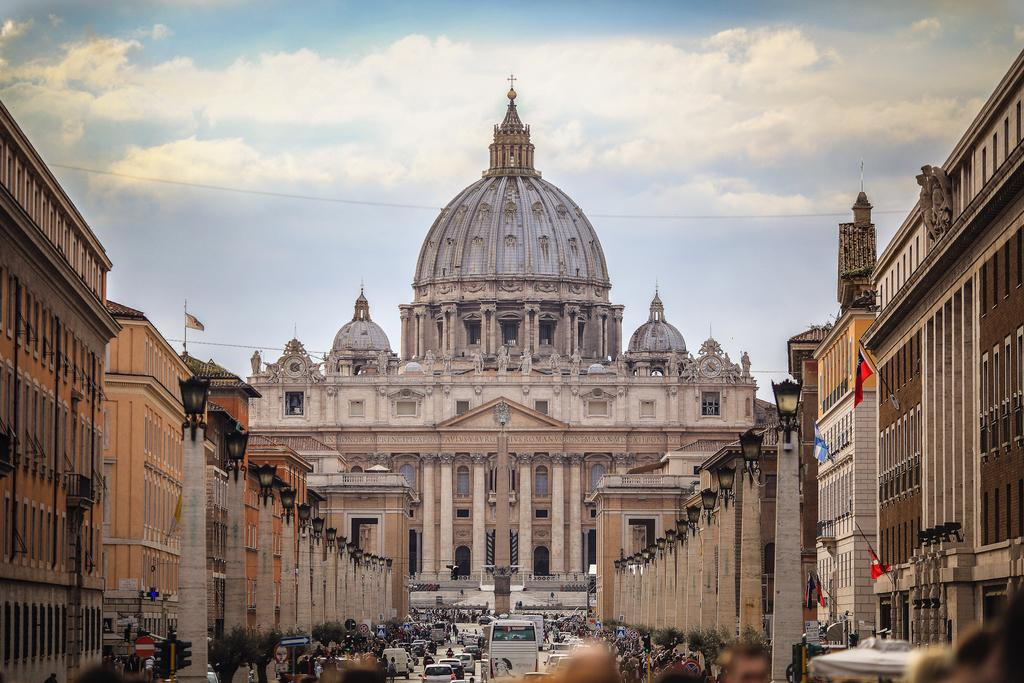What type of structures can be seen in the image? There are buildings in the image. What type of lighting is present in the image? Street lamps are present in the image. What type of transportation is visible in the image? Vehicles are visible in the image. Are there any people present in the image? Yes, there are people in the image. What type of symbol is present in the image? Flags are present in the image. What type of traffic control device is visible in the image? Traffic signals are visible in the image. What part of the natural environment is visible in the image? The sky is visible in the image. What type of atmospheric feature is present in the sky? Clouds are present in the image. What type of chalk is being used to draw on the ground in the image? There is no chalk or drawing on the ground present in the image. What type of border is visible around the image? The image does not have a border; it is a photograph or digital image with edges. 